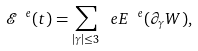<formula> <loc_0><loc_0><loc_500><loc_500>\mathcal { E } ^ { \ e } ( t ) = \sum _ { | \gamma | \leq 3 } \ e E ^ { \ e } ( \partial _ { \gamma } W ) ,</formula> 